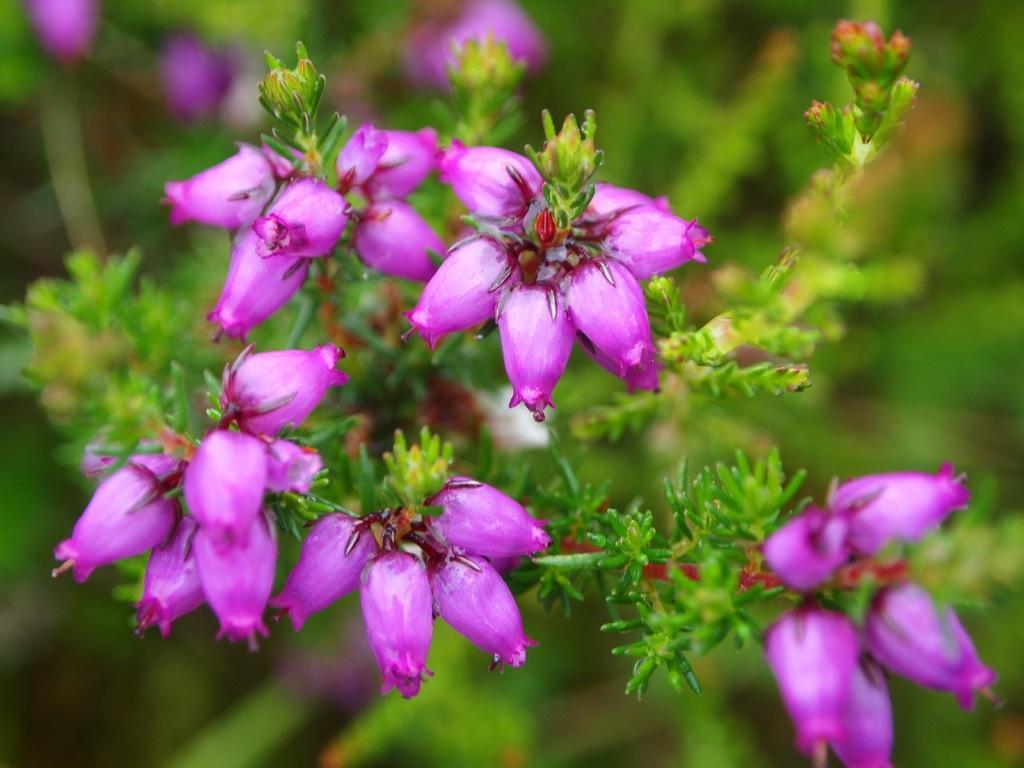Could you give a brief overview of what you see in this image? In this image there is a plant with violet color flowers, and there is blur background. 